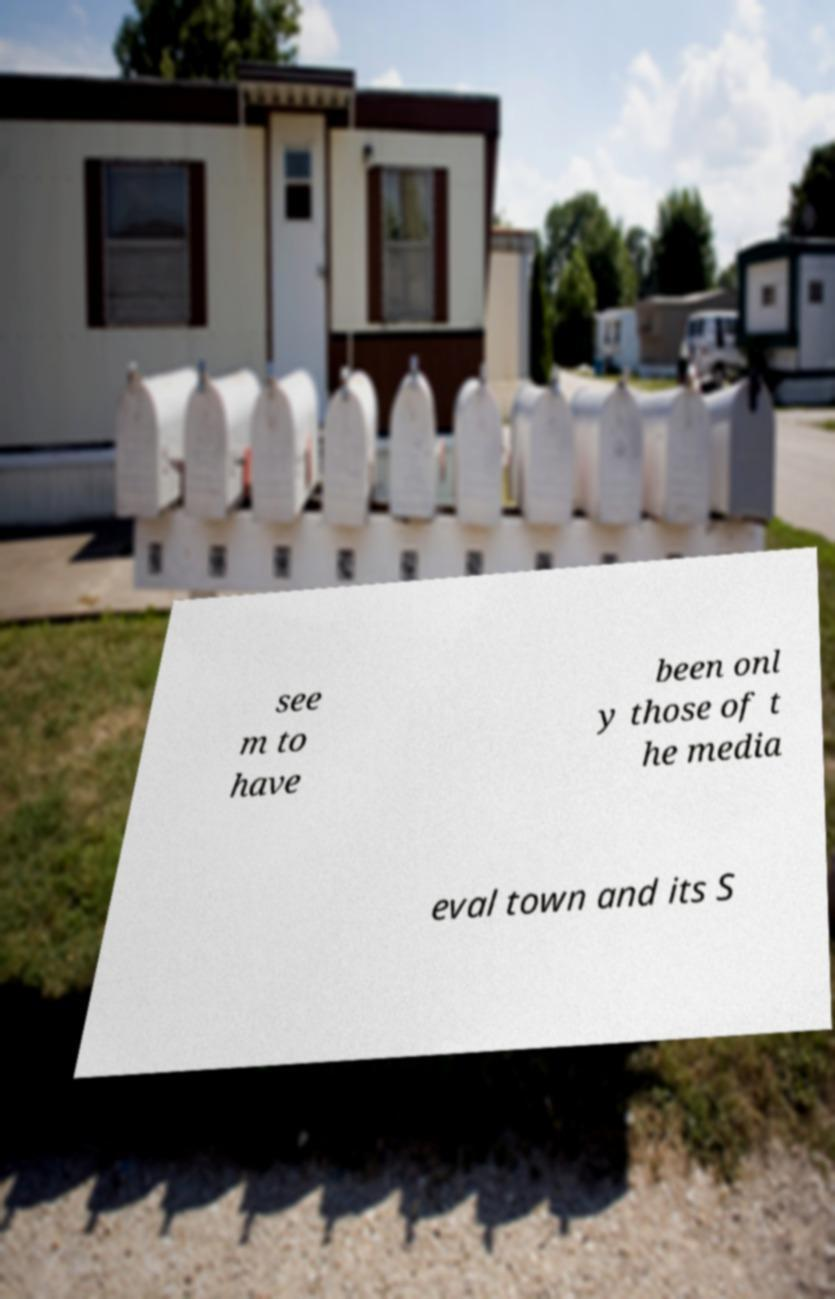Can you read and provide the text displayed in the image?This photo seems to have some interesting text. Can you extract and type it out for me? see m to have been onl y those of t he media eval town and its S 